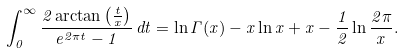<formula> <loc_0><loc_0><loc_500><loc_500>\int _ { 0 } ^ { \infty } { \frac { 2 \arctan \left ( { \frac { t } { x } } \right ) } { e ^ { 2 \pi t } - 1 } } \, { d } t = \ln \Gamma ( x ) - x \ln x + x - { \frac { 1 } { 2 } } \ln { \frac { 2 \pi } { x } } .</formula> 